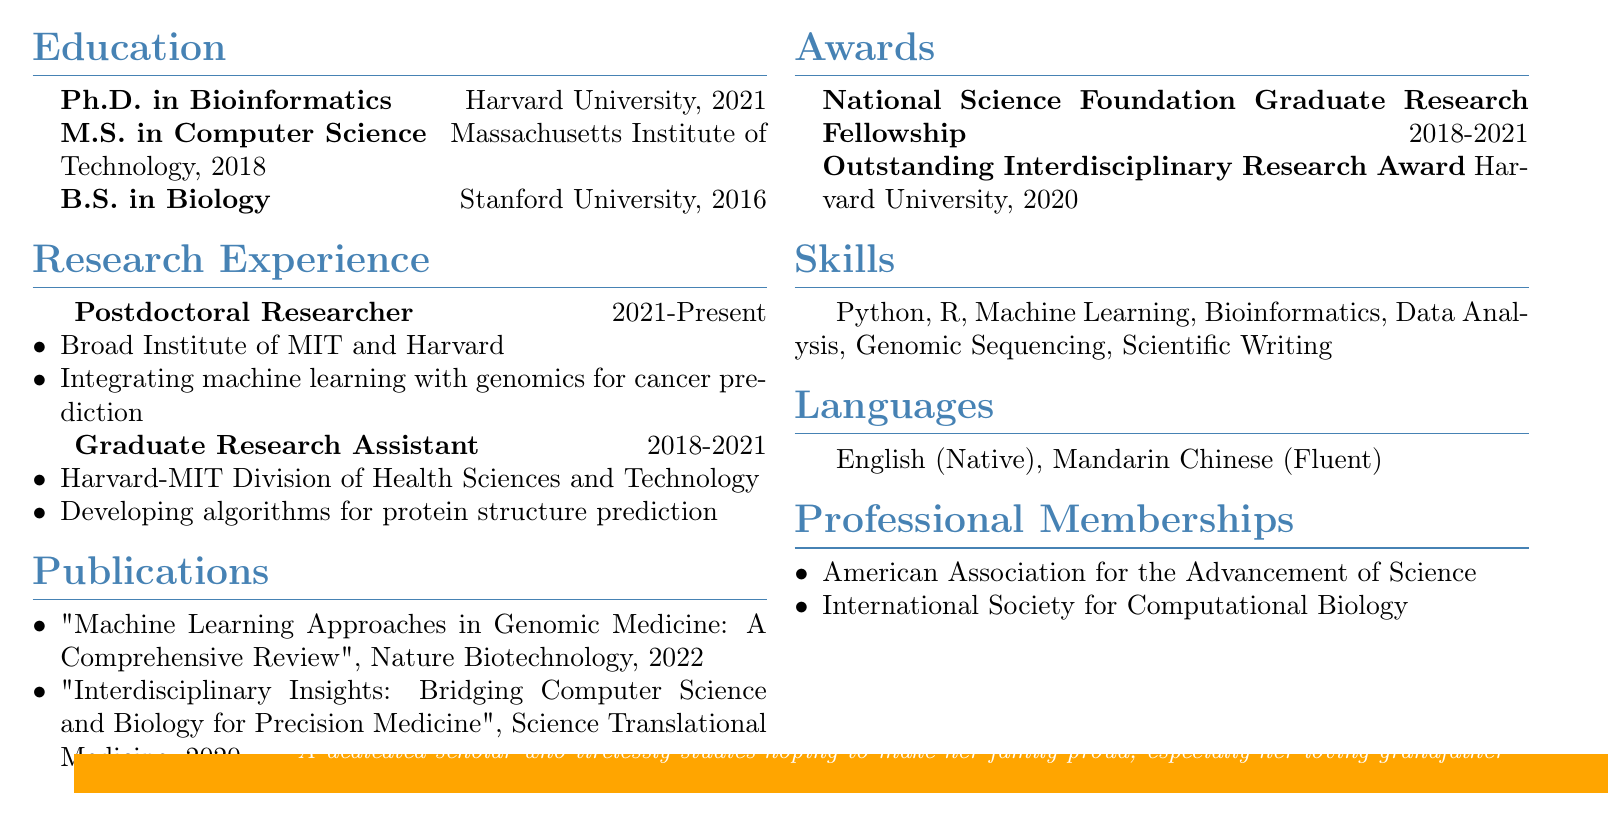what is Emily Chen's email address? The email address is listed under personal information in the document, which is emily.chen@email.com.
Answer: emily.chen@email.com which institution awarded the Outstanding Interdisciplinary Research Award? This award is mentioned under the awards section, where it's attributed to Harvard University.
Answer: Harvard University what degree does Emily Chen hold from Stanford University? The document includes educational qualifications, and it specifies that she earned a B.S. in Biology from Stanford University.
Answer: B.S. in Biology what is the title of Emily Chen's publication in Nature Biotechnology? This is found in the publications section of the resume, specifically under the year 2022.
Answer: Machine Learning Approaches in Genomic Medicine: A Comprehensive Review how many languages does Emily Chen speak fluently? The languages section indicates two languages that she speaks fluently: English and Mandarin Chinese.
Answer: 2 what is the duration of Emily Chen's current research position? The duration for the postdoctoral researcher position is listed as 2021-Present in the research experience section.
Answer: 2021-Present which research project did Emily Chen work on during her graduate assistantship? This information is found in the research experience section, detailing her responsibilities as a graduate research assistant.
Answer: Developing algorithms for protein structure prediction how many professional memberships does Emily Chen have listed? The professional memberships section lists two organizations to which she belongs.
Answer: 2 